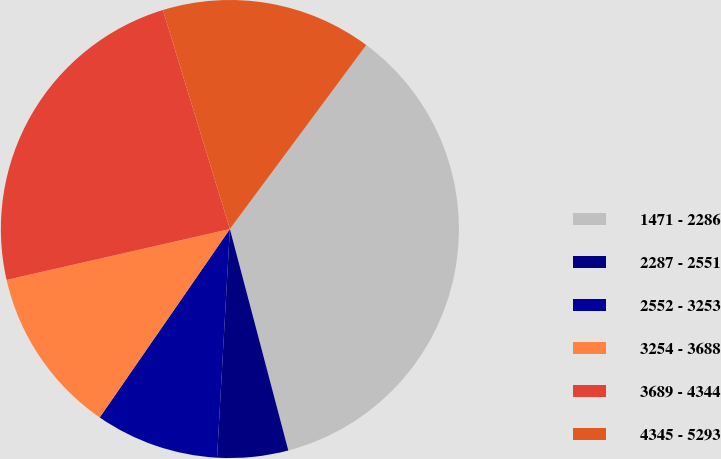Convert chart to OTSL. <chart><loc_0><loc_0><loc_500><loc_500><pie_chart><fcel>1471 - 2286<fcel>2287 - 2551<fcel>2552 - 3253<fcel>3254 - 3688<fcel>3689 - 4344<fcel>4345 - 5293<nl><fcel>35.74%<fcel>5.0%<fcel>8.73%<fcel>11.81%<fcel>23.84%<fcel>14.88%<nl></chart> 